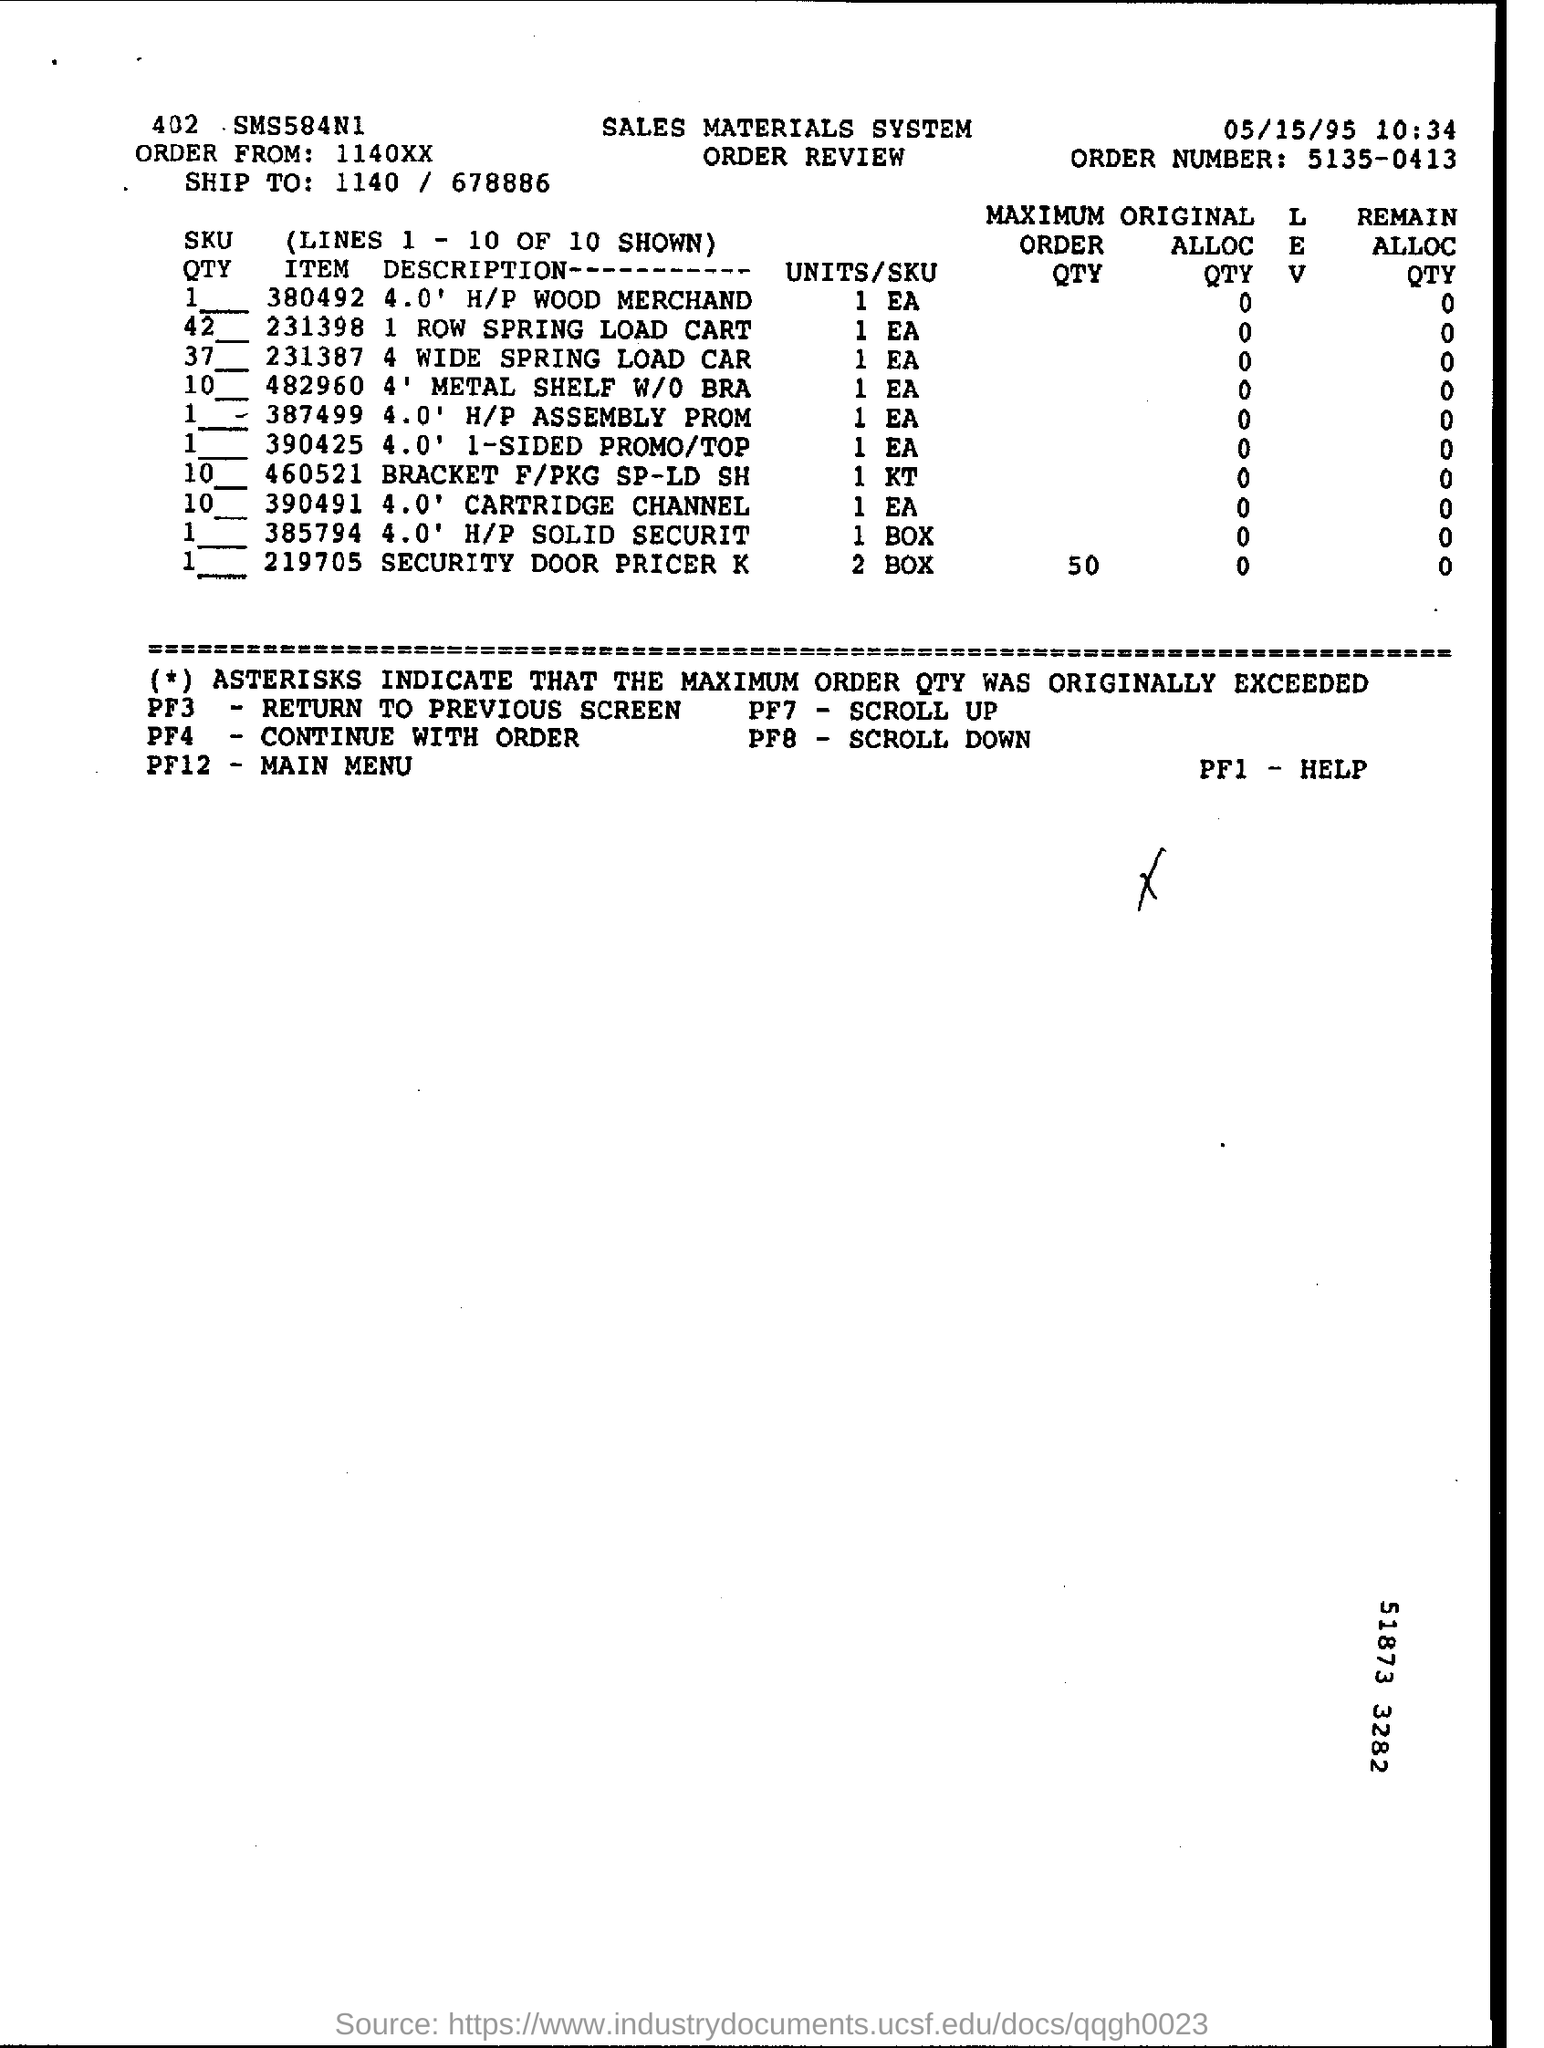Where is the order from?
Your response must be concise. 1140XX. What is the order number ?
Make the answer very short. 5135-0413. What is the maximum order quantity for item "219705"?
Give a very brief answer. 50. Mention the date at top of the page ?
Provide a short and direct response. 05/15/95. 